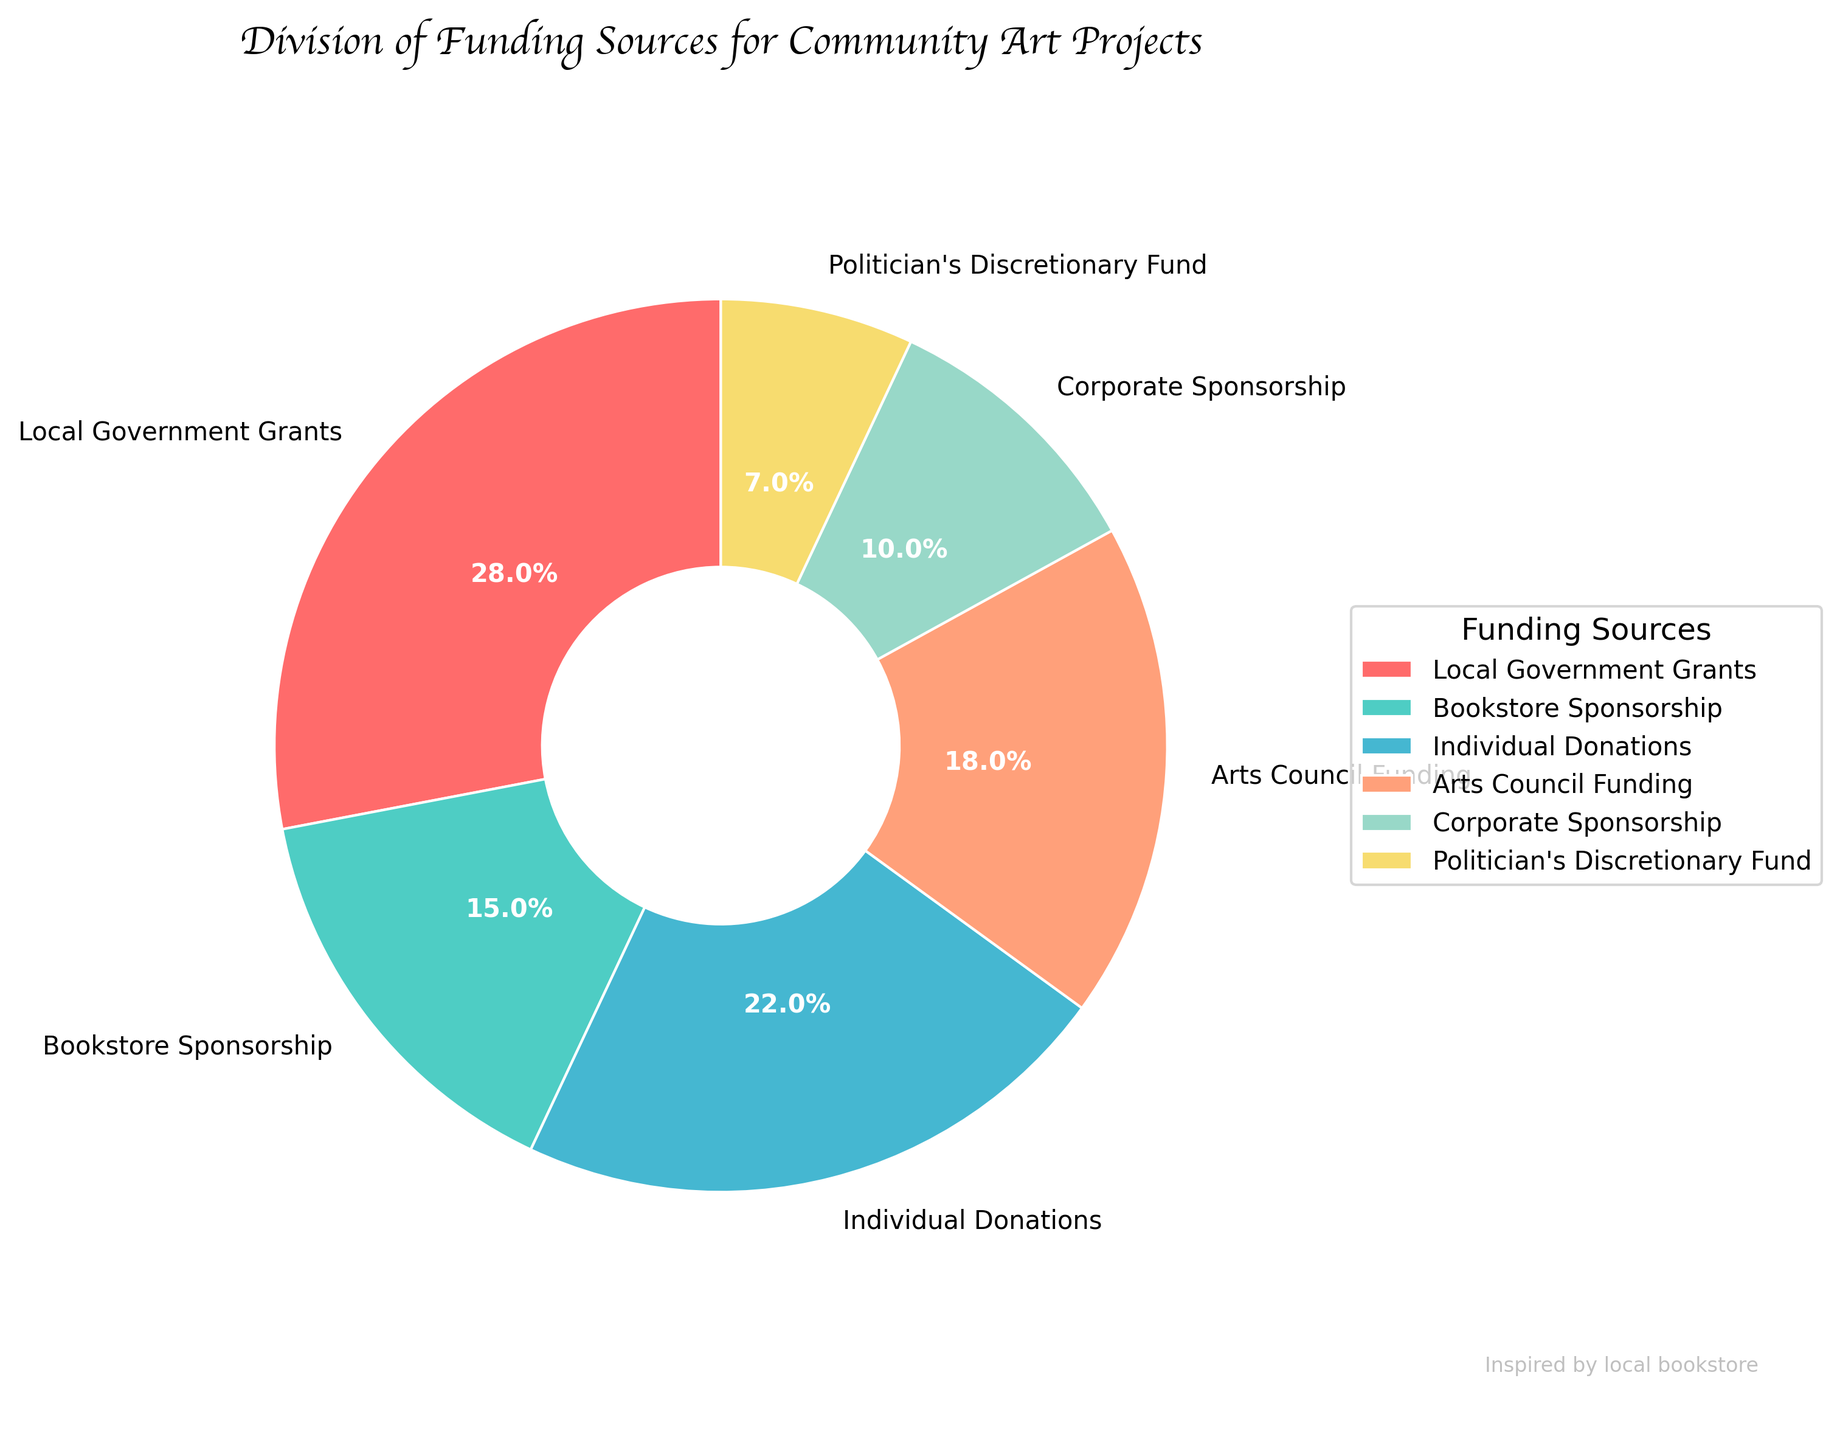what percentage of funding comes from the local government? The pie chart shows different sections labeled with their respective funding sources and percentages. Look for the section labeled 'Local Government Grants'.
Answer: 28% Is individual donations contributing more or less compared to corporate sponsorship? Look for both 'Individual Donations' and 'Corporate Sponsorship' in the pie chart, and compare their percentages. Individual Donations is 22% while Corporate Sponsorship is 10%, so Individual Donations contribute more.
Answer: more What is the total percentage of funding from grants and donations together? Sum the percentages of 'Local Government Grants', 'Individual Donations', and 'Arts Council Funding'. These values are: 28% + 22% + 18%. Add these up to get the total percentage. 28 + 22 + 18 = 68%.
Answer: 68% How does the support from the bookstore compare to the politician's discretionary fund? Look for 'Bookstore Sponsorship' and 'Politician's Discretionary Fund' on the pie chart and compare their percentages. Bookstore Sponsorship is 15% and Politician's Discretionary Fund is 7%. Bookstore support is higher.
Answer: Bookstore Sponsorship is higher If the corporate sponsorship doubled, what would its new total percentage be? The current percentage of corporate sponsorship is 10%. Doubling it means multiplying by 2: 10 * 2 = 20%.
Answer: 20% Which funding source has the lowest contribution? Identify the segment with the smallest percentage in the pie chart. The one with 7% is the smallest, which corresponds to the ‘Politician's Discretionary Fund’.
Answer: Politician's Discretionary Fund What colors represent Individual Donations and Arts Council Funding in the chart? Look at the pie chart sections labeled 'Individual Donations' and 'Arts Council Funding' and note their colors. Individual Donations is blue and Arts Council Funding is light coral.
Answer: Blue and light coral What is the difference between the percentage contributions of local government grants and corporate sponsorship? Subtract the percentage of 'Corporate Sponsorship' from 'Local Government Grants'. That is 28% - 10% = 18%.
Answer: 18% What percentage of funding comes from sources other than local government grants? Subtract the percentage of 'Local Government Grants' from 100%. That is 100% - 28% = 72%.
Answer: 72% 